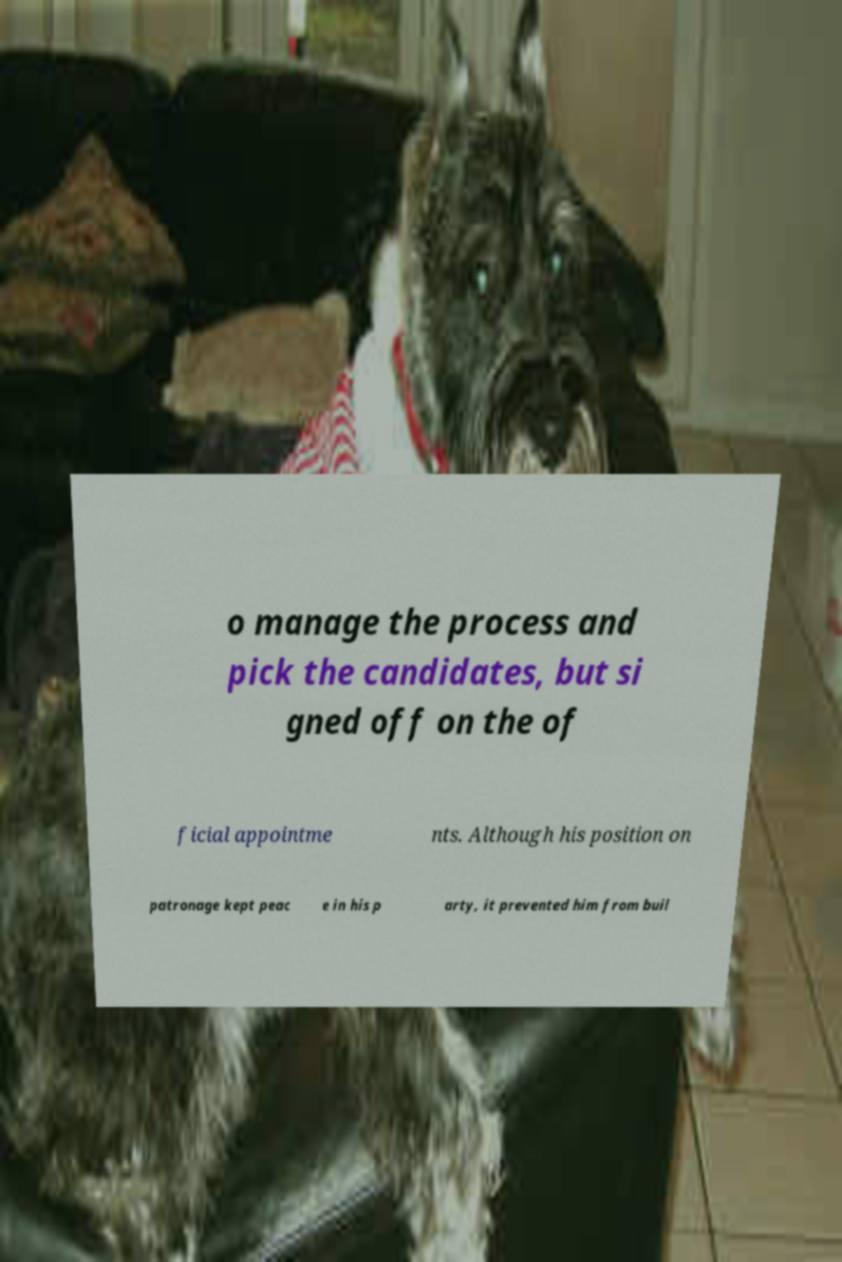Can you accurately transcribe the text from the provided image for me? o manage the process and pick the candidates, but si gned off on the of ficial appointme nts. Although his position on patronage kept peac e in his p arty, it prevented him from buil 